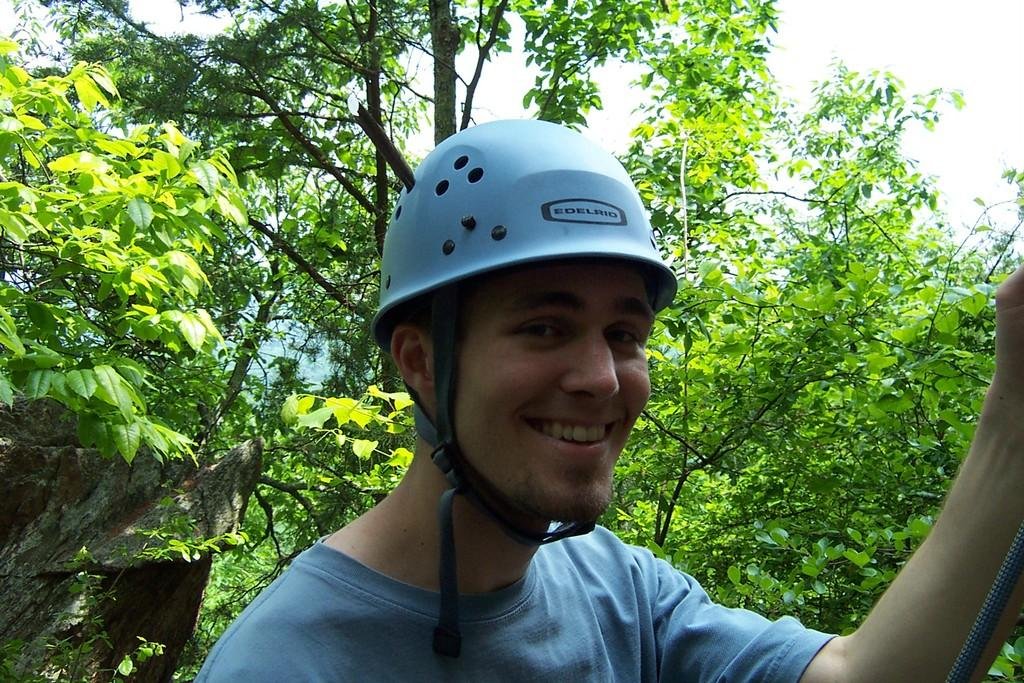What is the main subject of the image? There is a person in the image. What is the person's facial expression? The person is smiling. What is the person wearing on their head? The person is wearing a helmet. Can you describe the object in the image? Unfortunately, the facts provided do not give any information about the object in the image. What can be seen in the background of the image? There are trees and the sky visible in the background of the image. How many circles can be seen in the image? There is no mention of circles in the image, so it is impossible to determine their number. What type of cats are present in the image? There are no cats present in the image. Is the person in the image skating? The facts provided do not mention any activity the person is engaged in, so it cannot be determined if they are skating. 